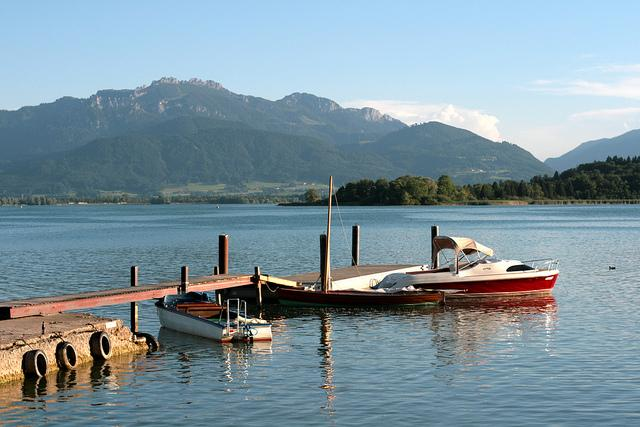What is the name of the platform used to walk out on the water? Please explain your reasoning. pier. A wood walkway extend out onto the water. 